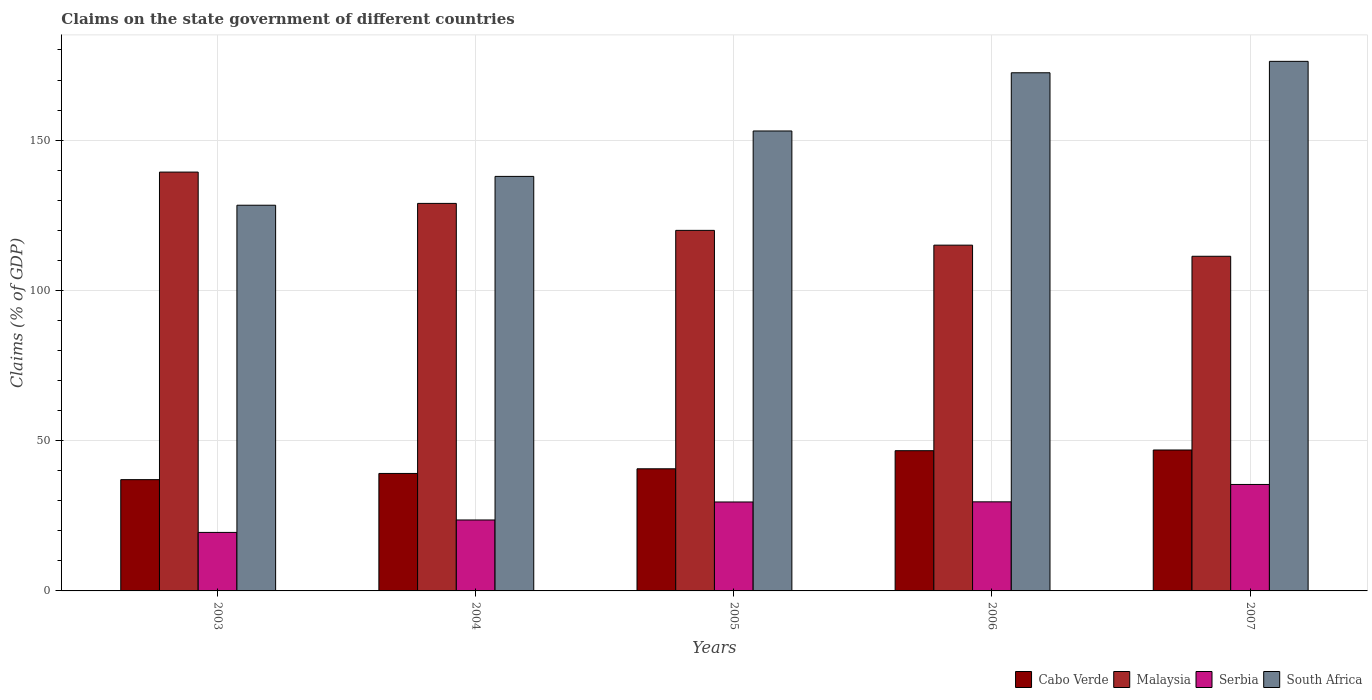How many groups of bars are there?
Make the answer very short. 5. Are the number of bars on each tick of the X-axis equal?
Ensure brevity in your answer.  Yes. In how many cases, is the number of bars for a given year not equal to the number of legend labels?
Keep it short and to the point. 0. What is the percentage of GDP claimed on the state government in Cabo Verde in 2007?
Offer a terse response. 46.89. Across all years, what is the maximum percentage of GDP claimed on the state government in Malaysia?
Offer a terse response. 139.37. Across all years, what is the minimum percentage of GDP claimed on the state government in South Africa?
Your answer should be very brief. 128.34. What is the total percentage of GDP claimed on the state government in Malaysia in the graph?
Provide a short and direct response. 614.69. What is the difference between the percentage of GDP claimed on the state government in Cabo Verde in 2006 and that in 2007?
Your response must be concise. -0.23. What is the difference between the percentage of GDP claimed on the state government in Malaysia in 2003 and the percentage of GDP claimed on the state government in South Africa in 2004?
Make the answer very short. 1.44. What is the average percentage of GDP claimed on the state government in Cabo Verde per year?
Provide a short and direct response. 42.06. In the year 2006, what is the difference between the percentage of GDP claimed on the state government in Cabo Verde and percentage of GDP claimed on the state government in Serbia?
Provide a short and direct response. 17.02. What is the ratio of the percentage of GDP claimed on the state government in South Africa in 2005 to that in 2006?
Your answer should be compact. 0.89. Is the difference between the percentage of GDP claimed on the state government in Cabo Verde in 2003 and 2006 greater than the difference between the percentage of GDP claimed on the state government in Serbia in 2003 and 2006?
Your response must be concise. Yes. What is the difference between the highest and the second highest percentage of GDP claimed on the state government in Malaysia?
Your answer should be compact. 10.42. What is the difference between the highest and the lowest percentage of GDP claimed on the state government in Malaysia?
Keep it short and to the point. 28.01. Is it the case that in every year, the sum of the percentage of GDP claimed on the state government in Malaysia and percentage of GDP claimed on the state government in Cabo Verde is greater than the sum of percentage of GDP claimed on the state government in Serbia and percentage of GDP claimed on the state government in South Africa?
Your answer should be very brief. Yes. What does the 3rd bar from the left in 2004 represents?
Ensure brevity in your answer.  Serbia. What does the 4th bar from the right in 2003 represents?
Ensure brevity in your answer.  Cabo Verde. Is it the case that in every year, the sum of the percentage of GDP claimed on the state government in Cabo Verde and percentage of GDP claimed on the state government in Malaysia is greater than the percentage of GDP claimed on the state government in South Africa?
Ensure brevity in your answer.  No. Are all the bars in the graph horizontal?
Provide a short and direct response. No. Does the graph contain grids?
Provide a succinct answer. Yes. How many legend labels are there?
Your answer should be very brief. 4. How are the legend labels stacked?
Your answer should be very brief. Horizontal. What is the title of the graph?
Ensure brevity in your answer.  Claims on the state government of different countries. Does "Haiti" appear as one of the legend labels in the graph?
Ensure brevity in your answer.  No. What is the label or title of the X-axis?
Ensure brevity in your answer.  Years. What is the label or title of the Y-axis?
Offer a very short reply. Claims (% of GDP). What is the Claims (% of GDP) in Cabo Verde in 2003?
Keep it short and to the point. 37.03. What is the Claims (% of GDP) of Malaysia in 2003?
Provide a succinct answer. 139.37. What is the Claims (% of GDP) in Serbia in 2003?
Keep it short and to the point. 19.47. What is the Claims (% of GDP) in South Africa in 2003?
Ensure brevity in your answer.  128.34. What is the Claims (% of GDP) in Cabo Verde in 2004?
Your answer should be very brief. 39.09. What is the Claims (% of GDP) of Malaysia in 2004?
Provide a short and direct response. 128.94. What is the Claims (% of GDP) of Serbia in 2004?
Offer a very short reply. 23.61. What is the Claims (% of GDP) of South Africa in 2004?
Ensure brevity in your answer.  137.93. What is the Claims (% of GDP) of Cabo Verde in 2005?
Your response must be concise. 40.64. What is the Claims (% of GDP) of Malaysia in 2005?
Give a very brief answer. 119.97. What is the Claims (% of GDP) of Serbia in 2005?
Offer a very short reply. 29.59. What is the Claims (% of GDP) in South Africa in 2005?
Your answer should be compact. 153.04. What is the Claims (% of GDP) in Cabo Verde in 2006?
Provide a succinct answer. 46.66. What is the Claims (% of GDP) of Malaysia in 2006?
Your answer should be compact. 115.05. What is the Claims (% of GDP) in Serbia in 2006?
Offer a terse response. 29.64. What is the Claims (% of GDP) in South Africa in 2006?
Provide a short and direct response. 172.41. What is the Claims (% of GDP) of Cabo Verde in 2007?
Give a very brief answer. 46.89. What is the Claims (% of GDP) of Malaysia in 2007?
Your answer should be very brief. 111.35. What is the Claims (% of GDP) in Serbia in 2007?
Offer a very short reply. 35.42. What is the Claims (% of GDP) in South Africa in 2007?
Ensure brevity in your answer.  176.21. Across all years, what is the maximum Claims (% of GDP) of Cabo Verde?
Offer a terse response. 46.89. Across all years, what is the maximum Claims (% of GDP) in Malaysia?
Provide a short and direct response. 139.37. Across all years, what is the maximum Claims (% of GDP) in Serbia?
Your response must be concise. 35.42. Across all years, what is the maximum Claims (% of GDP) of South Africa?
Offer a very short reply. 176.21. Across all years, what is the minimum Claims (% of GDP) of Cabo Verde?
Your answer should be compact. 37.03. Across all years, what is the minimum Claims (% of GDP) in Malaysia?
Ensure brevity in your answer.  111.35. Across all years, what is the minimum Claims (% of GDP) of Serbia?
Your answer should be very brief. 19.47. Across all years, what is the minimum Claims (% of GDP) of South Africa?
Ensure brevity in your answer.  128.34. What is the total Claims (% of GDP) of Cabo Verde in the graph?
Keep it short and to the point. 210.3. What is the total Claims (% of GDP) of Malaysia in the graph?
Give a very brief answer. 614.69. What is the total Claims (% of GDP) of Serbia in the graph?
Keep it short and to the point. 137.73. What is the total Claims (% of GDP) in South Africa in the graph?
Ensure brevity in your answer.  767.93. What is the difference between the Claims (% of GDP) of Cabo Verde in 2003 and that in 2004?
Your answer should be very brief. -2.06. What is the difference between the Claims (% of GDP) of Malaysia in 2003 and that in 2004?
Offer a terse response. 10.42. What is the difference between the Claims (% of GDP) in Serbia in 2003 and that in 2004?
Your answer should be very brief. -4.14. What is the difference between the Claims (% of GDP) of South Africa in 2003 and that in 2004?
Your response must be concise. -9.59. What is the difference between the Claims (% of GDP) in Cabo Verde in 2003 and that in 2005?
Ensure brevity in your answer.  -3.61. What is the difference between the Claims (% of GDP) of Malaysia in 2003 and that in 2005?
Your answer should be compact. 19.39. What is the difference between the Claims (% of GDP) of Serbia in 2003 and that in 2005?
Ensure brevity in your answer.  -10.13. What is the difference between the Claims (% of GDP) in South Africa in 2003 and that in 2005?
Keep it short and to the point. -24.7. What is the difference between the Claims (% of GDP) of Cabo Verde in 2003 and that in 2006?
Offer a terse response. -9.63. What is the difference between the Claims (% of GDP) of Malaysia in 2003 and that in 2006?
Offer a very short reply. 24.31. What is the difference between the Claims (% of GDP) of Serbia in 2003 and that in 2006?
Ensure brevity in your answer.  -10.17. What is the difference between the Claims (% of GDP) in South Africa in 2003 and that in 2006?
Provide a succinct answer. -44.07. What is the difference between the Claims (% of GDP) of Cabo Verde in 2003 and that in 2007?
Keep it short and to the point. -9.87. What is the difference between the Claims (% of GDP) in Malaysia in 2003 and that in 2007?
Give a very brief answer. 28.01. What is the difference between the Claims (% of GDP) of Serbia in 2003 and that in 2007?
Give a very brief answer. -15.96. What is the difference between the Claims (% of GDP) in South Africa in 2003 and that in 2007?
Give a very brief answer. -47.87. What is the difference between the Claims (% of GDP) of Cabo Verde in 2004 and that in 2005?
Your answer should be compact. -1.55. What is the difference between the Claims (% of GDP) in Malaysia in 2004 and that in 2005?
Offer a terse response. 8.97. What is the difference between the Claims (% of GDP) in Serbia in 2004 and that in 2005?
Your answer should be compact. -5.99. What is the difference between the Claims (% of GDP) in South Africa in 2004 and that in 2005?
Provide a short and direct response. -15.12. What is the difference between the Claims (% of GDP) of Cabo Verde in 2004 and that in 2006?
Keep it short and to the point. -7.57. What is the difference between the Claims (% of GDP) in Malaysia in 2004 and that in 2006?
Your answer should be compact. 13.89. What is the difference between the Claims (% of GDP) in Serbia in 2004 and that in 2006?
Keep it short and to the point. -6.03. What is the difference between the Claims (% of GDP) of South Africa in 2004 and that in 2006?
Keep it short and to the point. -34.48. What is the difference between the Claims (% of GDP) in Cabo Verde in 2004 and that in 2007?
Offer a terse response. -7.8. What is the difference between the Claims (% of GDP) in Malaysia in 2004 and that in 2007?
Keep it short and to the point. 17.59. What is the difference between the Claims (% of GDP) of Serbia in 2004 and that in 2007?
Keep it short and to the point. -11.82. What is the difference between the Claims (% of GDP) in South Africa in 2004 and that in 2007?
Your answer should be compact. -38.28. What is the difference between the Claims (% of GDP) in Cabo Verde in 2005 and that in 2006?
Keep it short and to the point. -6.02. What is the difference between the Claims (% of GDP) of Malaysia in 2005 and that in 2006?
Offer a very short reply. 4.92. What is the difference between the Claims (% of GDP) in Serbia in 2005 and that in 2006?
Provide a succinct answer. -0.05. What is the difference between the Claims (% of GDP) of South Africa in 2005 and that in 2006?
Your answer should be very brief. -19.37. What is the difference between the Claims (% of GDP) in Cabo Verde in 2005 and that in 2007?
Offer a terse response. -6.26. What is the difference between the Claims (% of GDP) of Malaysia in 2005 and that in 2007?
Keep it short and to the point. 8.62. What is the difference between the Claims (% of GDP) in Serbia in 2005 and that in 2007?
Offer a terse response. -5.83. What is the difference between the Claims (% of GDP) in South Africa in 2005 and that in 2007?
Provide a short and direct response. -23.17. What is the difference between the Claims (% of GDP) of Cabo Verde in 2006 and that in 2007?
Give a very brief answer. -0.23. What is the difference between the Claims (% of GDP) in Malaysia in 2006 and that in 2007?
Your answer should be compact. 3.7. What is the difference between the Claims (% of GDP) of Serbia in 2006 and that in 2007?
Make the answer very short. -5.78. What is the difference between the Claims (% of GDP) of South Africa in 2006 and that in 2007?
Make the answer very short. -3.8. What is the difference between the Claims (% of GDP) in Cabo Verde in 2003 and the Claims (% of GDP) in Malaysia in 2004?
Provide a short and direct response. -91.92. What is the difference between the Claims (% of GDP) in Cabo Verde in 2003 and the Claims (% of GDP) in Serbia in 2004?
Offer a very short reply. 13.42. What is the difference between the Claims (% of GDP) in Cabo Verde in 2003 and the Claims (% of GDP) in South Africa in 2004?
Ensure brevity in your answer.  -100.9. What is the difference between the Claims (% of GDP) in Malaysia in 2003 and the Claims (% of GDP) in Serbia in 2004?
Offer a very short reply. 115.76. What is the difference between the Claims (% of GDP) of Malaysia in 2003 and the Claims (% of GDP) of South Africa in 2004?
Ensure brevity in your answer.  1.44. What is the difference between the Claims (% of GDP) of Serbia in 2003 and the Claims (% of GDP) of South Africa in 2004?
Your response must be concise. -118.46. What is the difference between the Claims (% of GDP) in Cabo Verde in 2003 and the Claims (% of GDP) in Malaysia in 2005?
Offer a terse response. -82.95. What is the difference between the Claims (% of GDP) in Cabo Verde in 2003 and the Claims (% of GDP) in Serbia in 2005?
Offer a very short reply. 7.43. What is the difference between the Claims (% of GDP) of Cabo Verde in 2003 and the Claims (% of GDP) of South Africa in 2005?
Give a very brief answer. -116.02. What is the difference between the Claims (% of GDP) of Malaysia in 2003 and the Claims (% of GDP) of Serbia in 2005?
Your response must be concise. 109.77. What is the difference between the Claims (% of GDP) in Malaysia in 2003 and the Claims (% of GDP) in South Africa in 2005?
Provide a short and direct response. -13.68. What is the difference between the Claims (% of GDP) in Serbia in 2003 and the Claims (% of GDP) in South Africa in 2005?
Provide a succinct answer. -133.57. What is the difference between the Claims (% of GDP) of Cabo Verde in 2003 and the Claims (% of GDP) of Malaysia in 2006?
Your answer should be very brief. -78.03. What is the difference between the Claims (% of GDP) of Cabo Verde in 2003 and the Claims (% of GDP) of Serbia in 2006?
Provide a short and direct response. 7.39. What is the difference between the Claims (% of GDP) in Cabo Verde in 2003 and the Claims (% of GDP) in South Africa in 2006?
Make the answer very short. -135.38. What is the difference between the Claims (% of GDP) in Malaysia in 2003 and the Claims (% of GDP) in Serbia in 2006?
Give a very brief answer. 109.73. What is the difference between the Claims (% of GDP) in Malaysia in 2003 and the Claims (% of GDP) in South Africa in 2006?
Offer a terse response. -33.04. What is the difference between the Claims (% of GDP) in Serbia in 2003 and the Claims (% of GDP) in South Africa in 2006?
Offer a terse response. -152.94. What is the difference between the Claims (% of GDP) in Cabo Verde in 2003 and the Claims (% of GDP) in Malaysia in 2007?
Ensure brevity in your answer.  -74.33. What is the difference between the Claims (% of GDP) of Cabo Verde in 2003 and the Claims (% of GDP) of Serbia in 2007?
Ensure brevity in your answer.  1.6. What is the difference between the Claims (% of GDP) in Cabo Verde in 2003 and the Claims (% of GDP) in South Africa in 2007?
Offer a very short reply. -139.18. What is the difference between the Claims (% of GDP) of Malaysia in 2003 and the Claims (% of GDP) of Serbia in 2007?
Offer a very short reply. 103.94. What is the difference between the Claims (% of GDP) in Malaysia in 2003 and the Claims (% of GDP) in South Africa in 2007?
Make the answer very short. -36.84. What is the difference between the Claims (% of GDP) in Serbia in 2003 and the Claims (% of GDP) in South Africa in 2007?
Provide a succinct answer. -156.74. What is the difference between the Claims (% of GDP) of Cabo Verde in 2004 and the Claims (% of GDP) of Malaysia in 2005?
Keep it short and to the point. -80.88. What is the difference between the Claims (% of GDP) of Cabo Verde in 2004 and the Claims (% of GDP) of Serbia in 2005?
Ensure brevity in your answer.  9.49. What is the difference between the Claims (% of GDP) in Cabo Verde in 2004 and the Claims (% of GDP) in South Africa in 2005?
Give a very brief answer. -113.96. What is the difference between the Claims (% of GDP) in Malaysia in 2004 and the Claims (% of GDP) in Serbia in 2005?
Your response must be concise. 99.35. What is the difference between the Claims (% of GDP) in Malaysia in 2004 and the Claims (% of GDP) in South Africa in 2005?
Offer a terse response. -24.1. What is the difference between the Claims (% of GDP) of Serbia in 2004 and the Claims (% of GDP) of South Africa in 2005?
Offer a very short reply. -129.43. What is the difference between the Claims (% of GDP) in Cabo Verde in 2004 and the Claims (% of GDP) in Malaysia in 2006?
Provide a succinct answer. -75.96. What is the difference between the Claims (% of GDP) in Cabo Verde in 2004 and the Claims (% of GDP) in Serbia in 2006?
Provide a succinct answer. 9.45. What is the difference between the Claims (% of GDP) of Cabo Verde in 2004 and the Claims (% of GDP) of South Africa in 2006?
Your answer should be compact. -133.32. What is the difference between the Claims (% of GDP) of Malaysia in 2004 and the Claims (% of GDP) of Serbia in 2006?
Offer a terse response. 99.3. What is the difference between the Claims (% of GDP) in Malaysia in 2004 and the Claims (% of GDP) in South Africa in 2006?
Provide a short and direct response. -43.47. What is the difference between the Claims (% of GDP) in Serbia in 2004 and the Claims (% of GDP) in South Africa in 2006?
Your response must be concise. -148.8. What is the difference between the Claims (% of GDP) in Cabo Verde in 2004 and the Claims (% of GDP) in Malaysia in 2007?
Provide a succinct answer. -72.27. What is the difference between the Claims (% of GDP) in Cabo Verde in 2004 and the Claims (% of GDP) in Serbia in 2007?
Your response must be concise. 3.66. What is the difference between the Claims (% of GDP) of Cabo Verde in 2004 and the Claims (% of GDP) of South Africa in 2007?
Keep it short and to the point. -137.12. What is the difference between the Claims (% of GDP) of Malaysia in 2004 and the Claims (% of GDP) of Serbia in 2007?
Your answer should be compact. 93.52. What is the difference between the Claims (% of GDP) in Malaysia in 2004 and the Claims (% of GDP) in South Africa in 2007?
Ensure brevity in your answer.  -47.27. What is the difference between the Claims (% of GDP) in Serbia in 2004 and the Claims (% of GDP) in South Africa in 2007?
Your answer should be compact. -152.6. What is the difference between the Claims (% of GDP) of Cabo Verde in 2005 and the Claims (% of GDP) of Malaysia in 2006?
Give a very brief answer. -74.42. What is the difference between the Claims (% of GDP) in Cabo Verde in 2005 and the Claims (% of GDP) in Serbia in 2006?
Ensure brevity in your answer.  11. What is the difference between the Claims (% of GDP) in Cabo Verde in 2005 and the Claims (% of GDP) in South Africa in 2006?
Your answer should be very brief. -131.77. What is the difference between the Claims (% of GDP) of Malaysia in 2005 and the Claims (% of GDP) of Serbia in 2006?
Your answer should be very brief. 90.33. What is the difference between the Claims (% of GDP) of Malaysia in 2005 and the Claims (% of GDP) of South Africa in 2006?
Ensure brevity in your answer.  -52.44. What is the difference between the Claims (% of GDP) in Serbia in 2005 and the Claims (% of GDP) in South Africa in 2006?
Offer a terse response. -142.82. What is the difference between the Claims (% of GDP) in Cabo Verde in 2005 and the Claims (% of GDP) in Malaysia in 2007?
Make the answer very short. -70.72. What is the difference between the Claims (% of GDP) in Cabo Verde in 2005 and the Claims (% of GDP) in Serbia in 2007?
Ensure brevity in your answer.  5.21. What is the difference between the Claims (% of GDP) of Cabo Verde in 2005 and the Claims (% of GDP) of South Africa in 2007?
Make the answer very short. -135.57. What is the difference between the Claims (% of GDP) of Malaysia in 2005 and the Claims (% of GDP) of Serbia in 2007?
Ensure brevity in your answer.  84.55. What is the difference between the Claims (% of GDP) of Malaysia in 2005 and the Claims (% of GDP) of South Africa in 2007?
Ensure brevity in your answer.  -56.24. What is the difference between the Claims (% of GDP) of Serbia in 2005 and the Claims (% of GDP) of South Africa in 2007?
Your answer should be very brief. -146.62. What is the difference between the Claims (% of GDP) of Cabo Verde in 2006 and the Claims (% of GDP) of Malaysia in 2007?
Provide a short and direct response. -64.69. What is the difference between the Claims (% of GDP) of Cabo Verde in 2006 and the Claims (% of GDP) of Serbia in 2007?
Ensure brevity in your answer.  11.23. What is the difference between the Claims (% of GDP) of Cabo Verde in 2006 and the Claims (% of GDP) of South Africa in 2007?
Offer a terse response. -129.55. What is the difference between the Claims (% of GDP) of Malaysia in 2006 and the Claims (% of GDP) of Serbia in 2007?
Keep it short and to the point. 79.63. What is the difference between the Claims (% of GDP) in Malaysia in 2006 and the Claims (% of GDP) in South Africa in 2007?
Provide a short and direct response. -61.16. What is the difference between the Claims (% of GDP) in Serbia in 2006 and the Claims (% of GDP) in South Africa in 2007?
Offer a terse response. -146.57. What is the average Claims (% of GDP) in Cabo Verde per year?
Your answer should be compact. 42.06. What is the average Claims (% of GDP) of Malaysia per year?
Offer a terse response. 122.94. What is the average Claims (% of GDP) of Serbia per year?
Give a very brief answer. 27.55. What is the average Claims (% of GDP) in South Africa per year?
Provide a short and direct response. 153.59. In the year 2003, what is the difference between the Claims (% of GDP) of Cabo Verde and Claims (% of GDP) of Malaysia?
Your answer should be very brief. -102.34. In the year 2003, what is the difference between the Claims (% of GDP) of Cabo Verde and Claims (% of GDP) of Serbia?
Make the answer very short. 17.56. In the year 2003, what is the difference between the Claims (% of GDP) of Cabo Verde and Claims (% of GDP) of South Africa?
Your answer should be very brief. -91.31. In the year 2003, what is the difference between the Claims (% of GDP) of Malaysia and Claims (% of GDP) of Serbia?
Provide a succinct answer. 119.9. In the year 2003, what is the difference between the Claims (% of GDP) in Malaysia and Claims (% of GDP) in South Africa?
Offer a very short reply. 11.03. In the year 2003, what is the difference between the Claims (% of GDP) of Serbia and Claims (% of GDP) of South Africa?
Give a very brief answer. -108.87. In the year 2004, what is the difference between the Claims (% of GDP) of Cabo Verde and Claims (% of GDP) of Malaysia?
Provide a short and direct response. -89.86. In the year 2004, what is the difference between the Claims (% of GDP) of Cabo Verde and Claims (% of GDP) of Serbia?
Offer a terse response. 15.48. In the year 2004, what is the difference between the Claims (% of GDP) in Cabo Verde and Claims (% of GDP) in South Africa?
Provide a succinct answer. -98.84. In the year 2004, what is the difference between the Claims (% of GDP) of Malaysia and Claims (% of GDP) of Serbia?
Your answer should be very brief. 105.34. In the year 2004, what is the difference between the Claims (% of GDP) of Malaysia and Claims (% of GDP) of South Africa?
Give a very brief answer. -8.98. In the year 2004, what is the difference between the Claims (% of GDP) in Serbia and Claims (% of GDP) in South Africa?
Your answer should be very brief. -114.32. In the year 2005, what is the difference between the Claims (% of GDP) of Cabo Verde and Claims (% of GDP) of Malaysia?
Offer a terse response. -79.34. In the year 2005, what is the difference between the Claims (% of GDP) in Cabo Verde and Claims (% of GDP) in Serbia?
Your answer should be very brief. 11.04. In the year 2005, what is the difference between the Claims (% of GDP) in Cabo Verde and Claims (% of GDP) in South Africa?
Provide a succinct answer. -112.41. In the year 2005, what is the difference between the Claims (% of GDP) of Malaysia and Claims (% of GDP) of Serbia?
Give a very brief answer. 90.38. In the year 2005, what is the difference between the Claims (% of GDP) in Malaysia and Claims (% of GDP) in South Africa?
Offer a very short reply. -33.07. In the year 2005, what is the difference between the Claims (% of GDP) in Serbia and Claims (% of GDP) in South Africa?
Your answer should be compact. -123.45. In the year 2006, what is the difference between the Claims (% of GDP) in Cabo Verde and Claims (% of GDP) in Malaysia?
Your answer should be very brief. -68.39. In the year 2006, what is the difference between the Claims (% of GDP) in Cabo Verde and Claims (% of GDP) in Serbia?
Offer a terse response. 17.02. In the year 2006, what is the difference between the Claims (% of GDP) of Cabo Verde and Claims (% of GDP) of South Africa?
Offer a terse response. -125.75. In the year 2006, what is the difference between the Claims (% of GDP) of Malaysia and Claims (% of GDP) of Serbia?
Ensure brevity in your answer.  85.41. In the year 2006, what is the difference between the Claims (% of GDP) of Malaysia and Claims (% of GDP) of South Africa?
Provide a short and direct response. -57.36. In the year 2006, what is the difference between the Claims (% of GDP) of Serbia and Claims (% of GDP) of South Africa?
Keep it short and to the point. -142.77. In the year 2007, what is the difference between the Claims (% of GDP) in Cabo Verde and Claims (% of GDP) in Malaysia?
Offer a very short reply. -64.46. In the year 2007, what is the difference between the Claims (% of GDP) of Cabo Verde and Claims (% of GDP) of Serbia?
Offer a terse response. 11.47. In the year 2007, what is the difference between the Claims (% of GDP) of Cabo Verde and Claims (% of GDP) of South Africa?
Provide a short and direct response. -129.32. In the year 2007, what is the difference between the Claims (% of GDP) in Malaysia and Claims (% of GDP) in Serbia?
Give a very brief answer. 75.93. In the year 2007, what is the difference between the Claims (% of GDP) of Malaysia and Claims (% of GDP) of South Africa?
Your answer should be compact. -64.86. In the year 2007, what is the difference between the Claims (% of GDP) in Serbia and Claims (% of GDP) in South Africa?
Keep it short and to the point. -140.79. What is the ratio of the Claims (% of GDP) of Cabo Verde in 2003 to that in 2004?
Offer a terse response. 0.95. What is the ratio of the Claims (% of GDP) of Malaysia in 2003 to that in 2004?
Your answer should be compact. 1.08. What is the ratio of the Claims (% of GDP) of Serbia in 2003 to that in 2004?
Your answer should be very brief. 0.82. What is the ratio of the Claims (% of GDP) of South Africa in 2003 to that in 2004?
Your response must be concise. 0.93. What is the ratio of the Claims (% of GDP) in Cabo Verde in 2003 to that in 2005?
Your response must be concise. 0.91. What is the ratio of the Claims (% of GDP) of Malaysia in 2003 to that in 2005?
Ensure brevity in your answer.  1.16. What is the ratio of the Claims (% of GDP) in Serbia in 2003 to that in 2005?
Your answer should be very brief. 0.66. What is the ratio of the Claims (% of GDP) of South Africa in 2003 to that in 2005?
Ensure brevity in your answer.  0.84. What is the ratio of the Claims (% of GDP) in Cabo Verde in 2003 to that in 2006?
Offer a very short reply. 0.79. What is the ratio of the Claims (% of GDP) of Malaysia in 2003 to that in 2006?
Provide a succinct answer. 1.21. What is the ratio of the Claims (% of GDP) of Serbia in 2003 to that in 2006?
Your answer should be compact. 0.66. What is the ratio of the Claims (% of GDP) of South Africa in 2003 to that in 2006?
Make the answer very short. 0.74. What is the ratio of the Claims (% of GDP) in Cabo Verde in 2003 to that in 2007?
Your answer should be very brief. 0.79. What is the ratio of the Claims (% of GDP) of Malaysia in 2003 to that in 2007?
Offer a very short reply. 1.25. What is the ratio of the Claims (% of GDP) of Serbia in 2003 to that in 2007?
Your answer should be very brief. 0.55. What is the ratio of the Claims (% of GDP) of South Africa in 2003 to that in 2007?
Offer a very short reply. 0.73. What is the ratio of the Claims (% of GDP) of Cabo Verde in 2004 to that in 2005?
Your answer should be compact. 0.96. What is the ratio of the Claims (% of GDP) of Malaysia in 2004 to that in 2005?
Your answer should be compact. 1.07. What is the ratio of the Claims (% of GDP) in Serbia in 2004 to that in 2005?
Your response must be concise. 0.8. What is the ratio of the Claims (% of GDP) in South Africa in 2004 to that in 2005?
Keep it short and to the point. 0.9. What is the ratio of the Claims (% of GDP) of Cabo Verde in 2004 to that in 2006?
Offer a terse response. 0.84. What is the ratio of the Claims (% of GDP) in Malaysia in 2004 to that in 2006?
Offer a terse response. 1.12. What is the ratio of the Claims (% of GDP) in Serbia in 2004 to that in 2006?
Offer a very short reply. 0.8. What is the ratio of the Claims (% of GDP) of South Africa in 2004 to that in 2006?
Give a very brief answer. 0.8. What is the ratio of the Claims (% of GDP) in Cabo Verde in 2004 to that in 2007?
Ensure brevity in your answer.  0.83. What is the ratio of the Claims (% of GDP) of Malaysia in 2004 to that in 2007?
Your response must be concise. 1.16. What is the ratio of the Claims (% of GDP) in Serbia in 2004 to that in 2007?
Provide a succinct answer. 0.67. What is the ratio of the Claims (% of GDP) of South Africa in 2004 to that in 2007?
Your answer should be very brief. 0.78. What is the ratio of the Claims (% of GDP) in Cabo Verde in 2005 to that in 2006?
Your answer should be very brief. 0.87. What is the ratio of the Claims (% of GDP) of Malaysia in 2005 to that in 2006?
Your response must be concise. 1.04. What is the ratio of the Claims (% of GDP) of South Africa in 2005 to that in 2006?
Provide a succinct answer. 0.89. What is the ratio of the Claims (% of GDP) in Cabo Verde in 2005 to that in 2007?
Your response must be concise. 0.87. What is the ratio of the Claims (% of GDP) in Malaysia in 2005 to that in 2007?
Your answer should be compact. 1.08. What is the ratio of the Claims (% of GDP) in Serbia in 2005 to that in 2007?
Your response must be concise. 0.84. What is the ratio of the Claims (% of GDP) of South Africa in 2005 to that in 2007?
Keep it short and to the point. 0.87. What is the ratio of the Claims (% of GDP) in Malaysia in 2006 to that in 2007?
Provide a short and direct response. 1.03. What is the ratio of the Claims (% of GDP) of Serbia in 2006 to that in 2007?
Provide a short and direct response. 0.84. What is the ratio of the Claims (% of GDP) of South Africa in 2006 to that in 2007?
Your answer should be compact. 0.98. What is the difference between the highest and the second highest Claims (% of GDP) in Cabo Verde?
Make the answer very short. 0.23. What is the difference between the highest and the second highest Claims (% of GDP) of Malaysia?
Offer a very short reply. 10.42. What is the difference between the highest and the second highest Claims (% of GDP) in Serbia?
Keep it short and to the point. 5.78. What is the difference between the highest and the second highest Claims (% of GDP) in South Africa?
Your answer should be very brief. 3.8. What is the difference between the highest and the lowest Claims (% of GDP) of Cabo Verde?
Keep it short and to the point. 9.87. What is the difference between the highest and the lowest Claims (% of GDP) of Malaysia?
Provide a succinct answer. 28.01. What is the difference between the highest and the lowest Claims (% of GDP) of Serbia?
Your response must be concise. 15.96. What is the difference between the highest and the lowest Claims (% of GDP) of South Africa?
Keep it short and to the point. 47.87. 